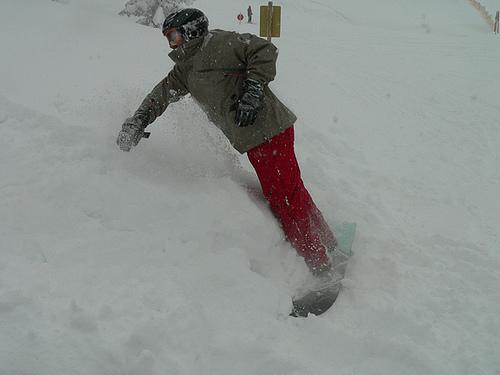Write a short advertisement text promoting the gray winter ski jacket worn by the snowboarder. Stay warm and stylish on the slopes with our versatile gray winter ski jacket. Designed for the perfect balance of comfort and function. Dare to be bold this winter season! Ask a yes-or-no question related to the image. Is the snowboarder wearing goggles? List the colors of the signs visible in the image. There are no signs visible in the image. Mention the color of the ski jacket being worn by the snowboarder and the type of headgear on their head. The snowboarder is wearing a plain gray ski jacket and a black ski helmet. What is the person doing in the background on the ski trail? There is no person visible in the background on the ski trail. Identify the color of the snowboarder's pants and goggles. The snowboarder is wearing bright red ski pants and black-rimmed ski goggles. Explain the placement of the orange object in the image. There is no orange object visible in the image. For the multi-choice VQA task, provide a question with four options, with the suitable answer included. What color are the snowboarder's pants? a) Blue b) Green c) Red d) Yellow Describe the state of the snow in the scene and the snowboard's appearance. The snow in the scene is thick and fresh powdery. The snowboard is mostly covered in snow, making its color difficult to discern. 